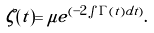Convert formula to latex. <formula><loc_0><loc_0><loc_500><loc_500>\zeta ( t ) = \mu e ^ { ( - 2 \int \Gamma ( t ) d t ) } .</formula> 